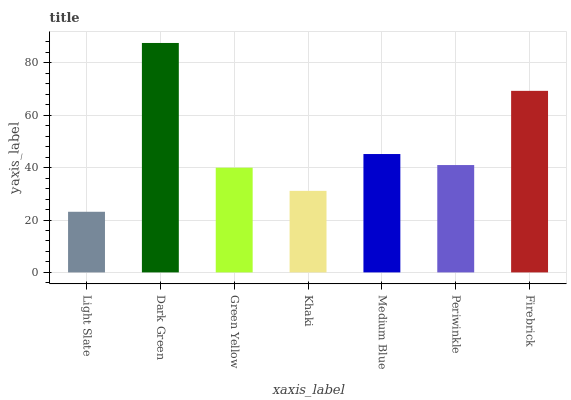Is Light Slate the minimum?
Answer yes or no. Yes. Is Dark Green the maximum?
Answer yes or no. Yes. Is Green Yellow the minimum?
Answer yes or no. No. Is Green Yellow the maximum?
Answer yes or no. No. Is Dark Green greater than Green Yellow?
Answer yes or no. Yes. Is Green Yellow less than Dark Green?
Answer yes or no. Yes. Is Green Yellow greater than Dark Green?
Answer yes or no. No. Is Dark Green less than Green Yellow?
Answer yes or no. No. Is Periwinkle the high median?
Answer yes or no. Yes. Is Periwinkle the low median?
Answer yes or no. Yes. Is Dark Green the high median?
Answer yes or no. No. Is Medium Blue the low median?
Answer yes or no. No. 